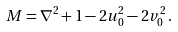Convert formula to latex. <formula><loc_0><loc_0><loc_500><loc_500>M = \nabla ^ { 2 } + 1 - 2 u _ { 0 } ^ { 2 } - 2 v _ { 0 } ^ { 2 } \, .</formula> 